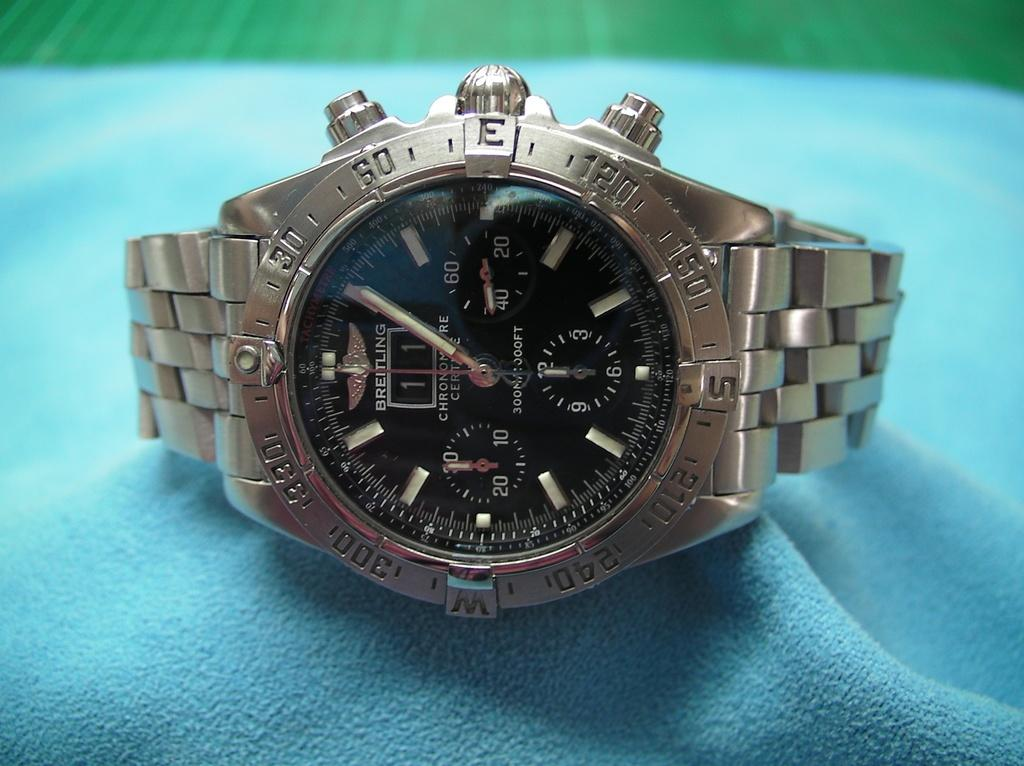What object is the main focus of the image? There is a watch in the image. What is the color of the watch? The watch is silver in color. What is the background of the watch in the image? The watch is on a blue surface. Can you tell me how many planes are visible in the image? There are no planes visible in the image; it features a watch on a blue surface. What type of vein is present in the image? There is no vein present in the image; it features a watch on a blue surface. 